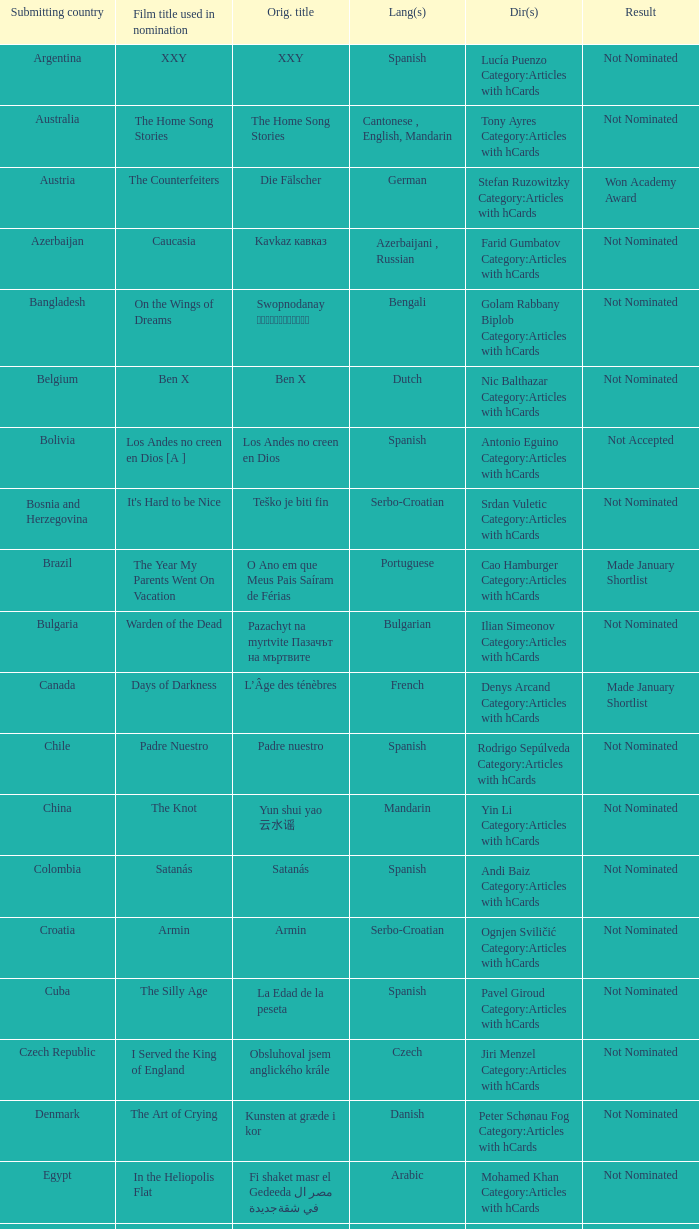What country submitted miehen työ? Finland. 